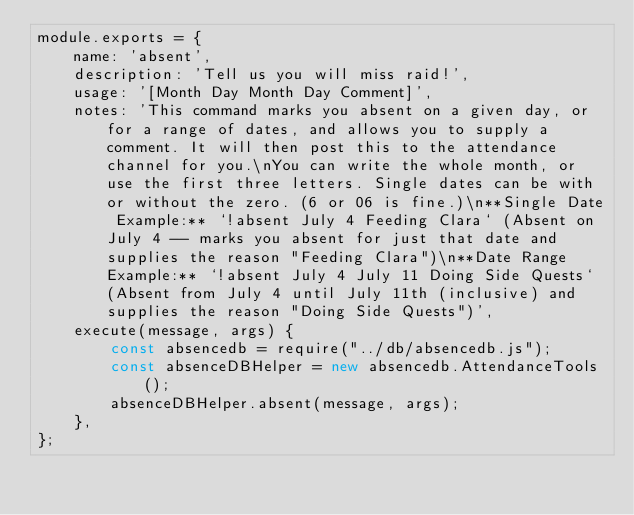<code> <loc_0><loc_0><loc_500><loc_500><_JavaScript_>module.exports = {
	name: 'absent',
	description: 'Tell us you will miss raid!',
	usage: '[Month Day Month Day Comment]',
	notes: 'This command marks you absent on a given day, or for a range of dates, and allows you to supply a comment. It will then post this to the attendance channel for you.\nYou can write the whole month, or use the first three letters. Single dates can be with or without the zero. (6 or 06 is fine.)\n**Single Date Example:** `!absent July 4 Feeding Clara` (Absent on July 4 -- marks you absent for just that date and supplies the reason "Feeding Clara")\n**Date Range Example:** `!absent July 4 July 11 Doing Side Quests` (Absent from July 4 until July 11th (inclusive) and supplies the reason "Doing Side Quests")',
	execute(message, args) {
        const absencedb = require("../db/absencedb.js");
        const absenceDBHelper = new absencedb.AttendanceTools();
		absenceDBHelper.absent(message, args);
	},
};</code> 